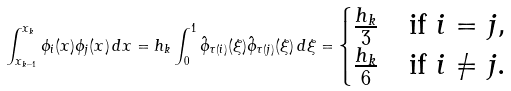<formula> <loc_0><loc_0><loc_500><loc_500>\int _ { x _ { k - 1 } } ^ { x _ { k } } \phi _ { i } ( x ) \phi _ { j } ( x ) \, d x = h _ { k } \int _ { 0 } ^ { 1 } \hat { \phi } _ { \tau ( i ) } ( \xi ) \hat { \phi } _ { \tau ( j ) } ( \xi ) \, d \xi = \begin{cases} \frac { h _ { k } } 3 & \text {if } i = j , \\ \frac { h _ { k } } 6 & \text {if } i \neq j . \end{cases}</formula> 